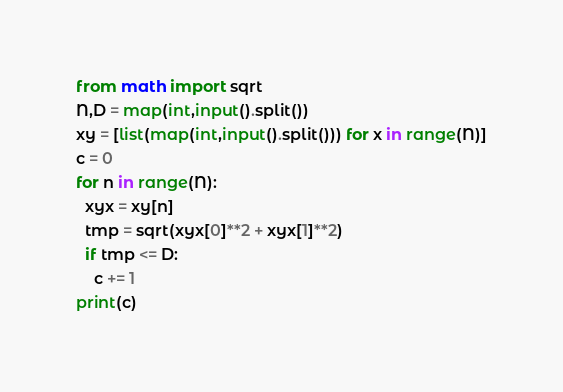<code> <loc_0><loc_0><loc_500><loc_500><_Python_>from math import sqrt
N,D = map(int,input().split())
xy = [list(map(int,input().split())) for x in range(N)]
c = 0
for n in range(N):
  xyx = xy[n]
  tmp = sqrt(xyx[0]**2 + xyx[1]**2)
  if tmp <= D:
    c += 1
print(c)</code> 